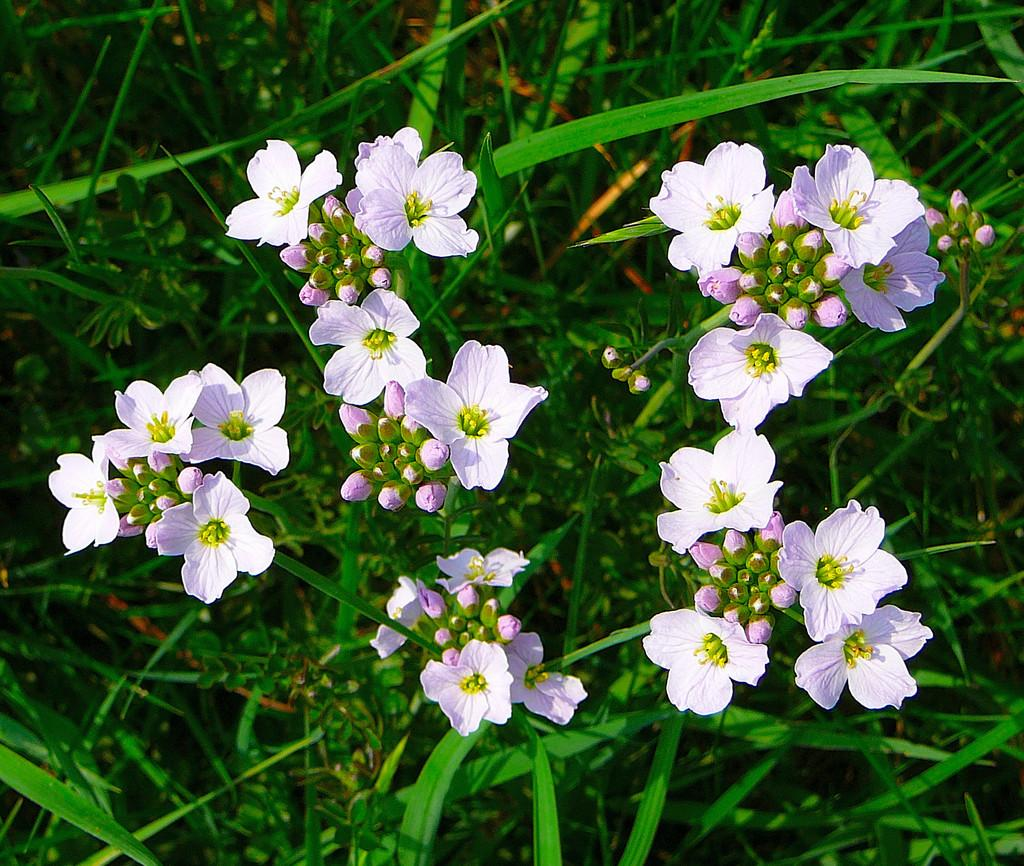What type of living organisms can be seen in the image? There are flowers in the image. What can be seen in the background of the image? There are plants in the background of the image. What color are the plants in the image? The plants are green in color. What type of wool is being used to make the bells in the image? There are no bells or wool present in the image; it features flowers and plants. 